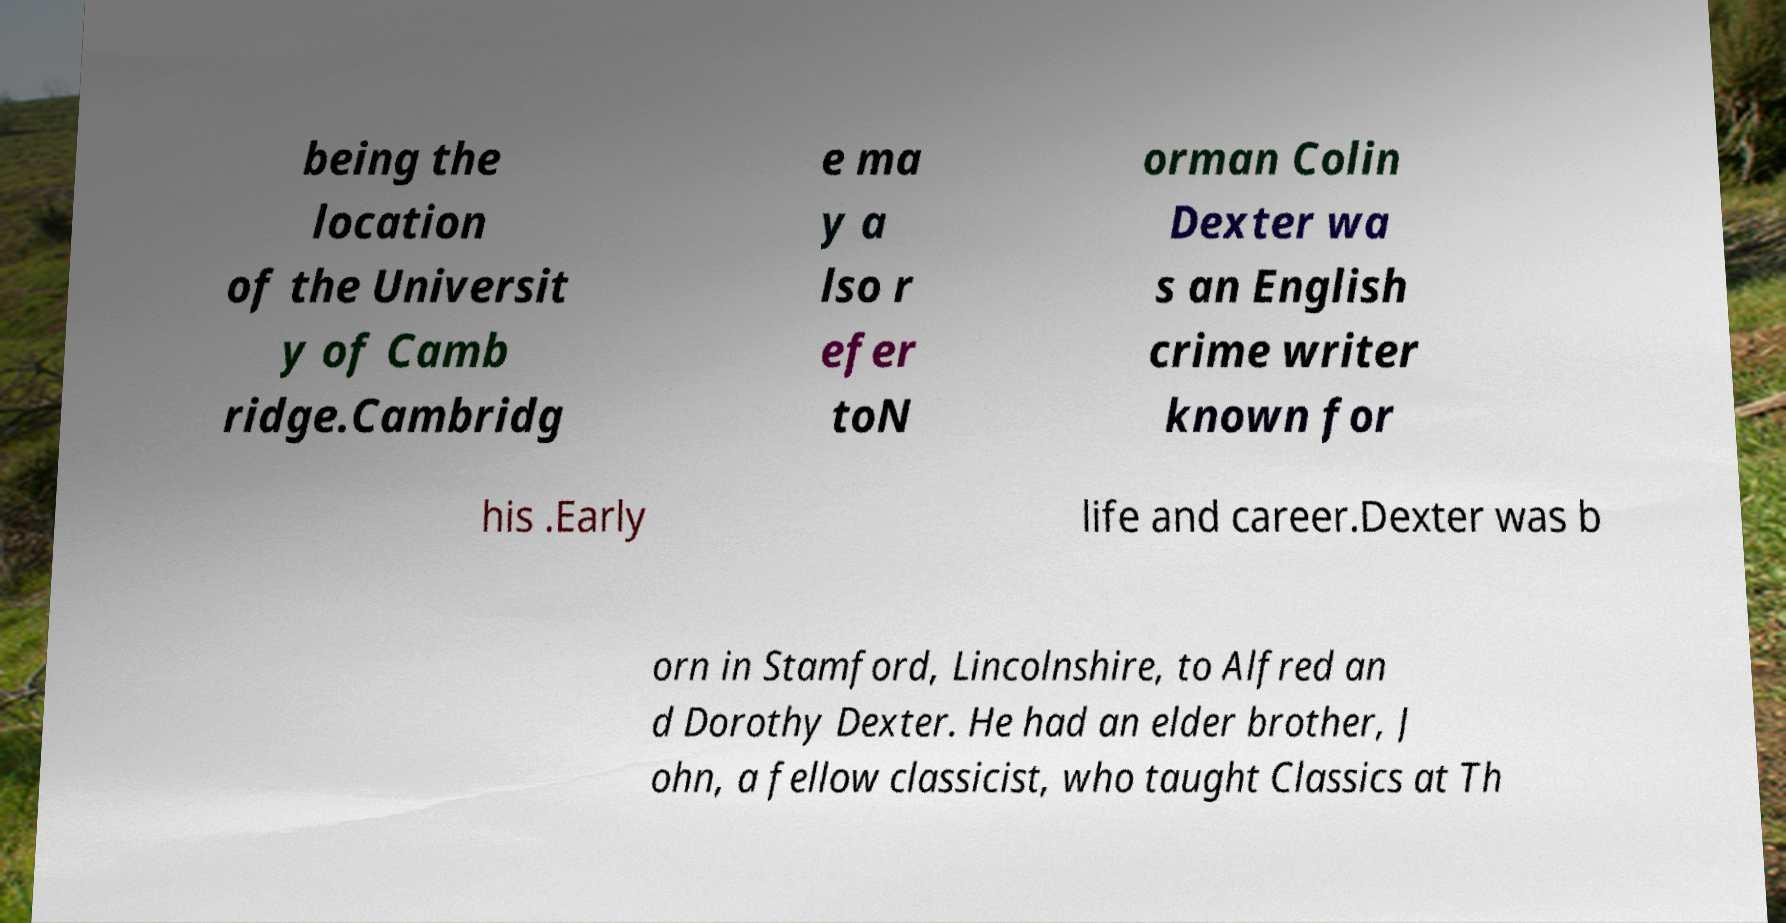Can you accurately transcribe the text from the provided image for me? being the location of the Universit y of Camb ridge.Cambridg e ma y a lso r efer toN orman Colin Dexter wa s an English crime writer known for his .Early life and career.Dexter was b orn in Stamford, Lincolnshire, to Alfred an d Dorothy Dexter. He had an elder brother, J ohn, a fellow classicist, who taught Classics at Th 